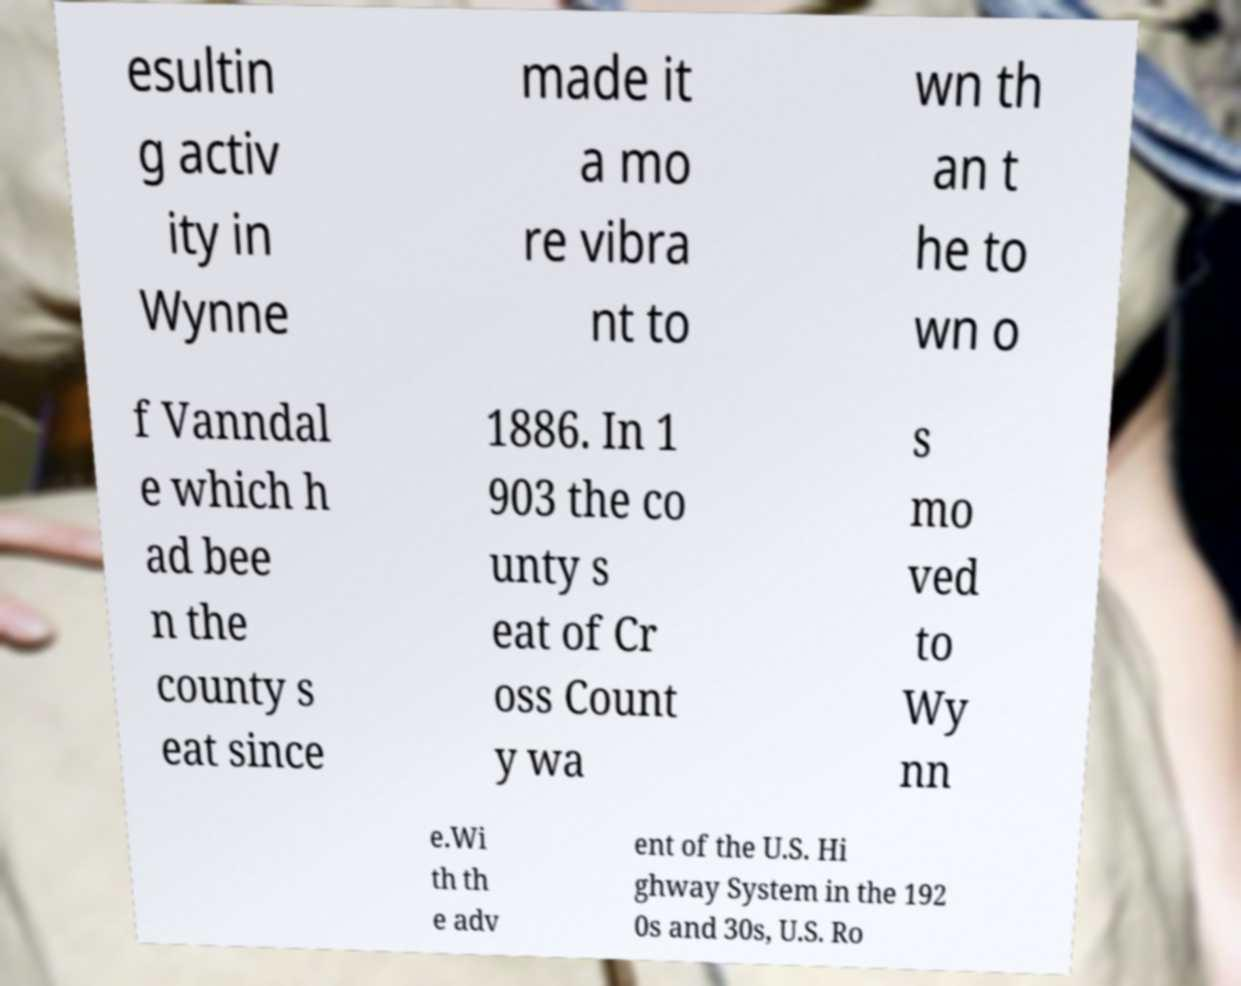For documentation purposes, I need the text within this image transcribed. Could you provide that? esultin g activ ity in Wynne made it a mo re vibra nt to wn th an t he to wn o f Vanndal e which h ad bee n the county s eat since 1886. In 1 903 the co unty s eat of Cr oss Count y wa s mo ved to Wy nn e.Wi th th e adv ent of the U.S. Hi ghway System in the 192 0s and 30s, U.S. Ro 